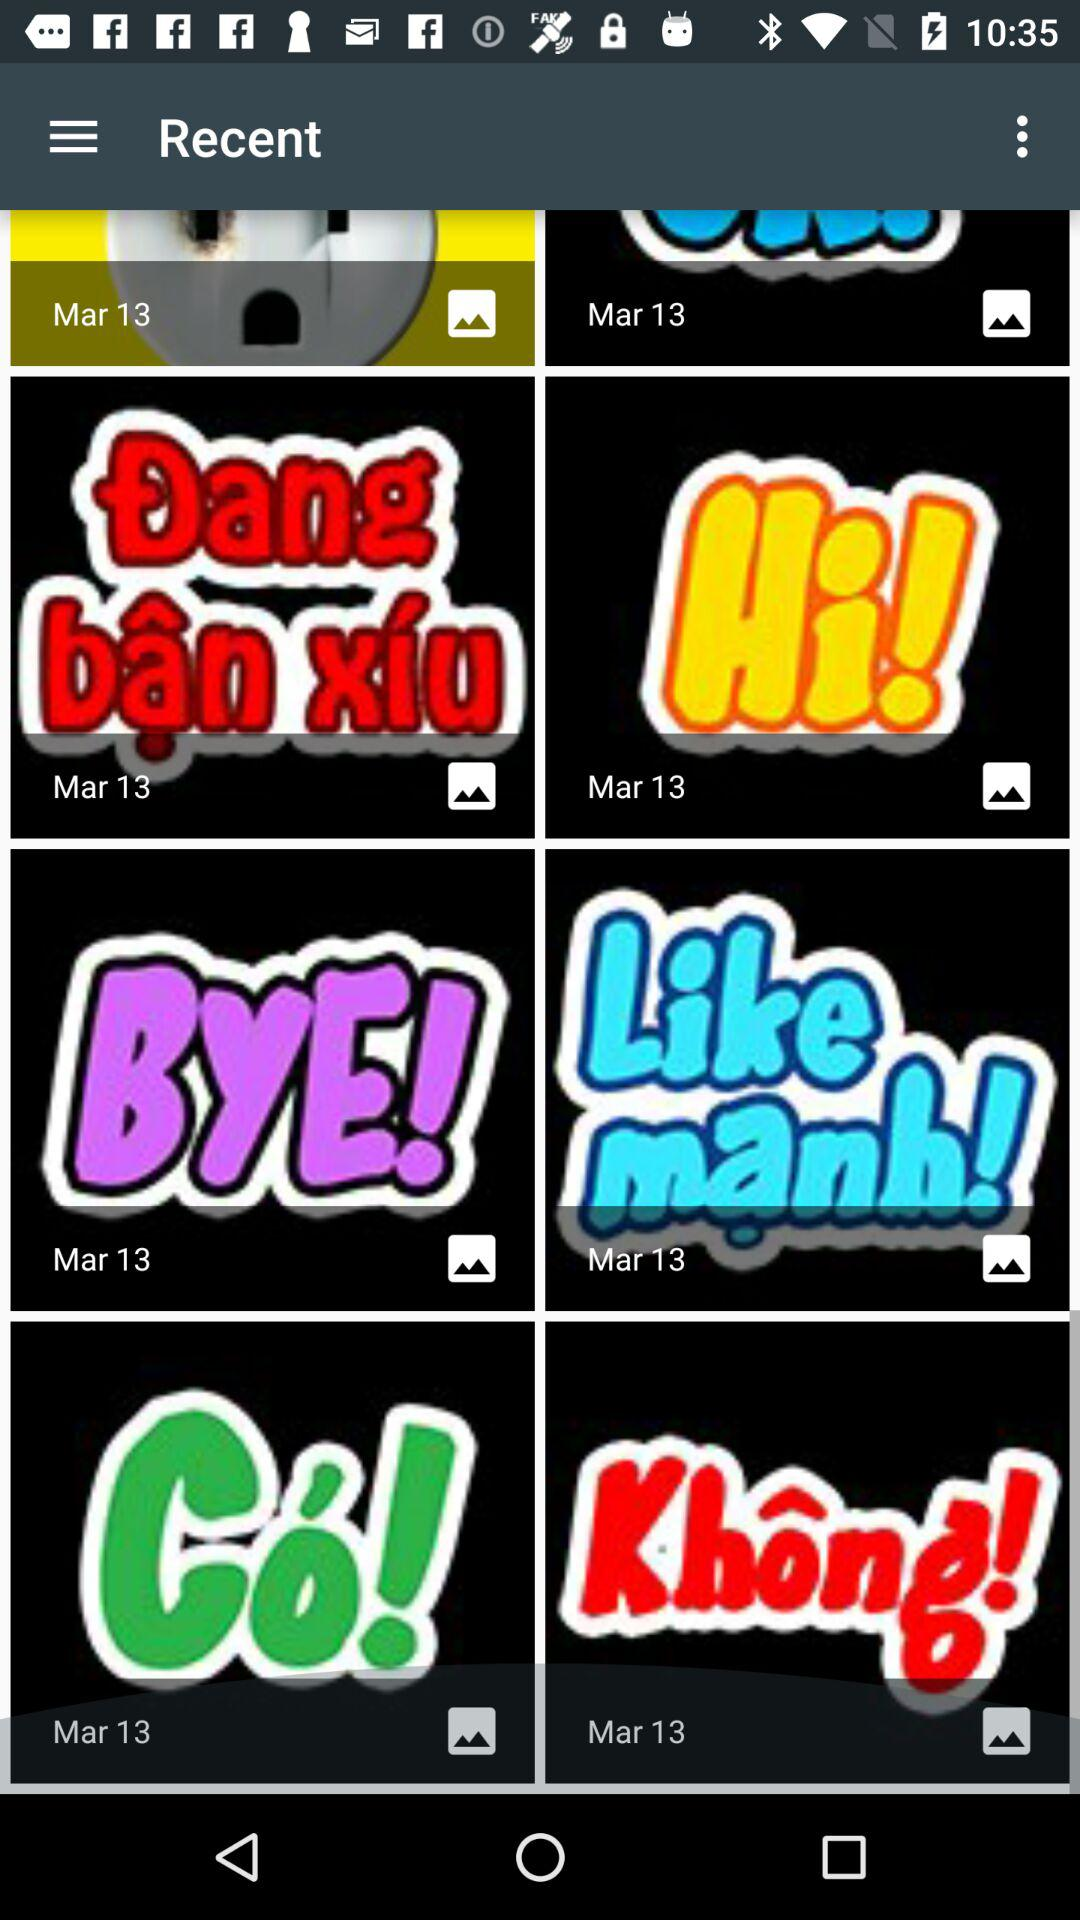What is the date of the gif "Hi!"? The date is March 13. 